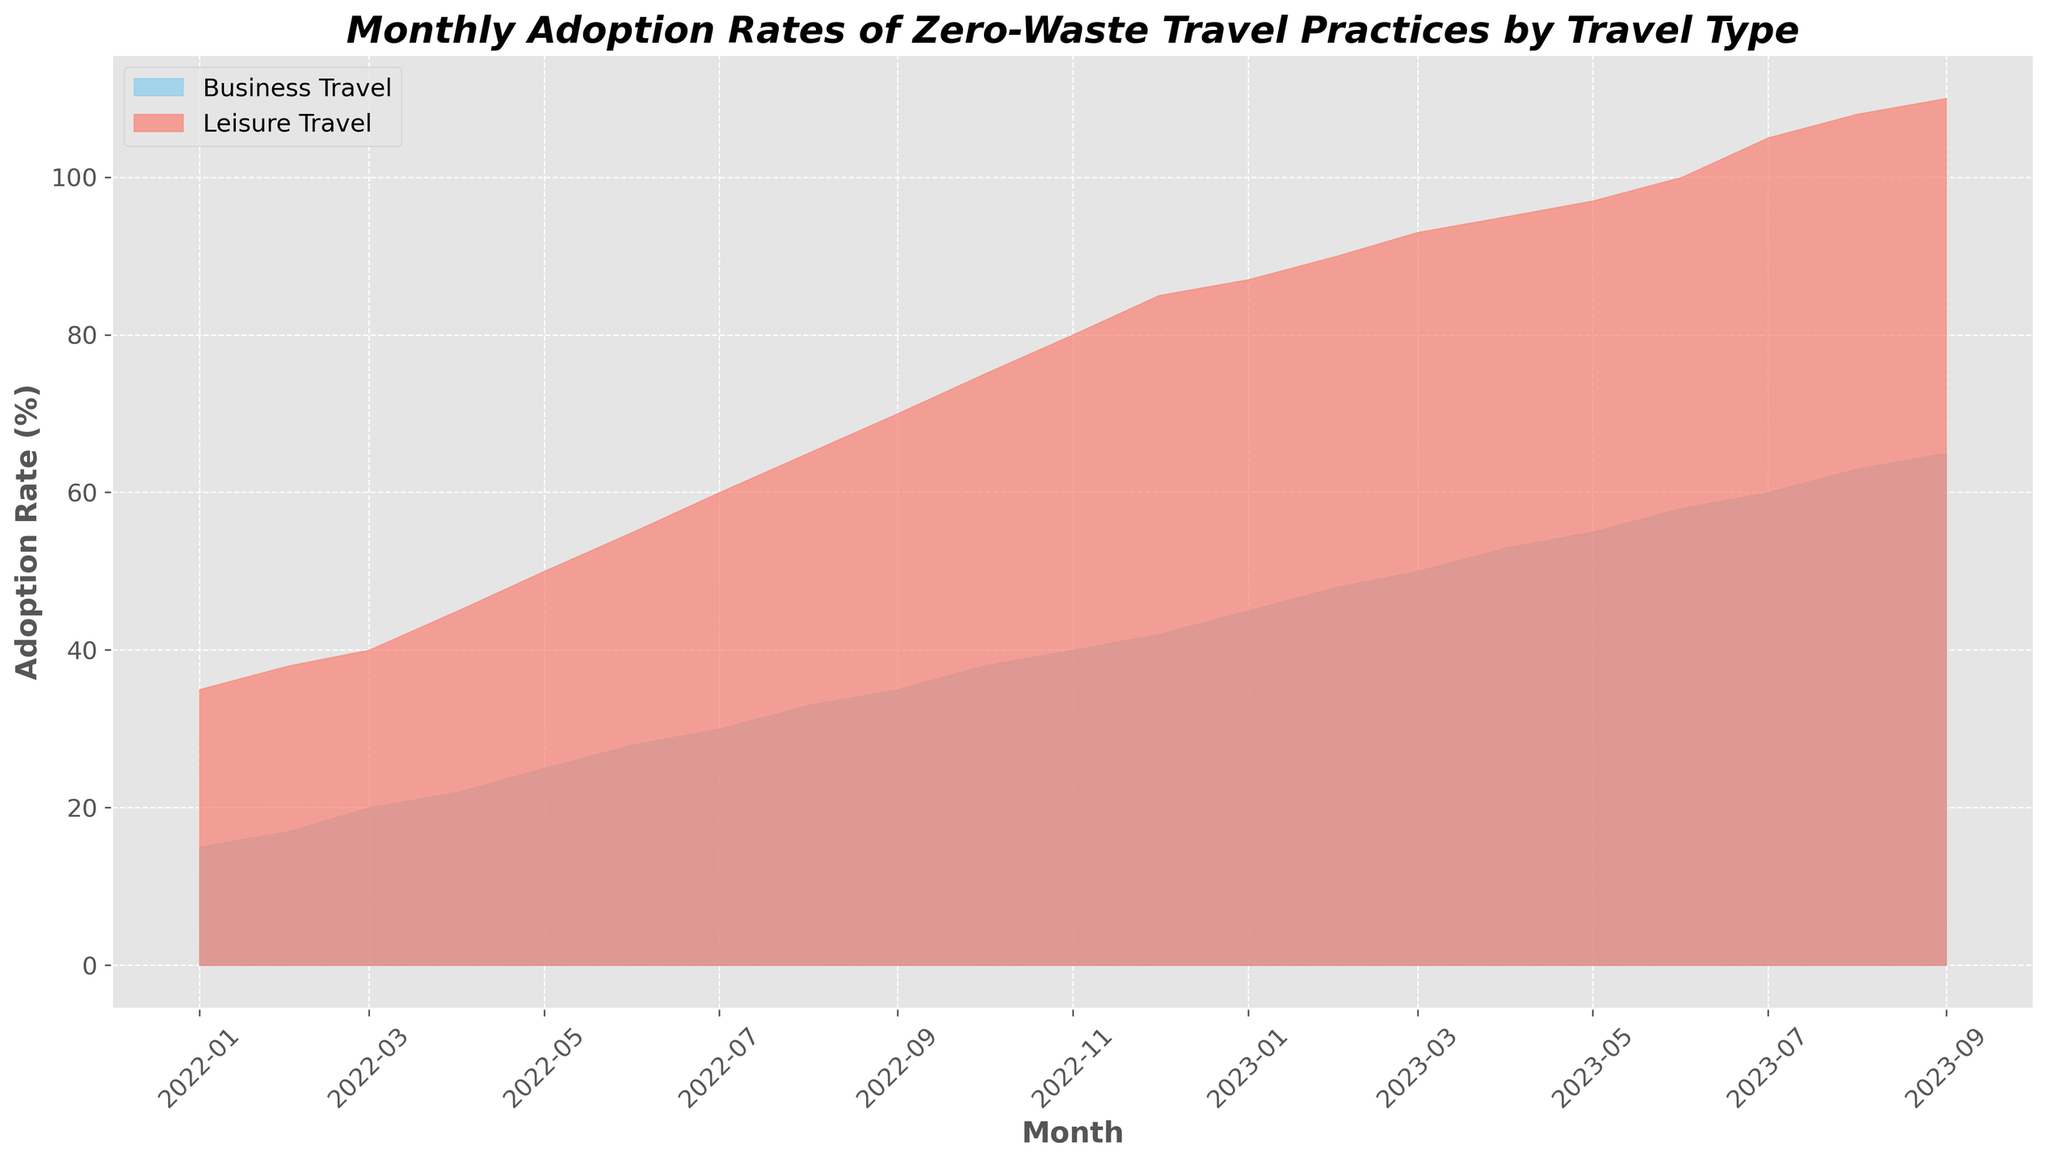What's the adoption rate difference between Business and Leisure Travel in January 2023? To find the difference in adoption rates for January 2023, locate the adoption rates for both Business Travel and Leisure Travel on the chart at January 2023. The rate for Business Travel is 45% and for Leisure Travel is 87%. Subtract the Business rate from the Leisure rate: 87% - 45% = 42%
Answer: 42% In which month did Leisure Travel first reach an adoption rate of 100%? Check the Leisure Travel line on the chart and find the month when it first hits 100%. According to the data, leisure travel reaches 100% adoption in June 2023
Answer: June 2023 Which type of travel shows a more rapid increase in adoption rates between January 2022 and December 2022? Compare the adoption rates of both travel types from January 2022 to December 2022. Business Travel rates increased from 15% to 42%, which is a 27% increase. Leisure Travel rates increased from 35% to 85%, which is a 50% increase. Hence, Leisure Travel shows a more rapid increase
Answer: Leisure Travel What is the average adoption rate for Business Travel from January 2022 to September 2023? To find the average, add up the monthly adoption rates for Business Travel from January 2022 to September 2023 and then divide by the number of months (21). The sum is 798. Dividing this by 21 gives 798 / 21 = 38%
Answer: 38% During which month is the gap between Business and Leisure Travel adoption rates smallest? Identify the month with the smallest difference between adoption rates for Business and Leisure Travel. The smallest difference is in September 2023, with Business at 65% and Leisure at 110%; the difference is 45%, which is the smallest gap
Answer: September 2023 How many months did it take for Business Travel to reach an adoption rate of 50%? Check the Business Travel line on the chart to determine the month it first reaches 50%, which is March 2023. This is from January 2022 to March 2023, which is 15 months
Answer: 15 months In July 2023, by how much did the adoption rate for Leisure Travel exceed that for Business Travel? Look at the adoption rates for both travel types in July 2023. Business Travel is at 60%, and Leisure Travel is at 105%. The difference is 105% - 60% = 45%
Answer: 45% What's the total sum of adoption rates for Leisure Travel from January 2022 to June 2022? Add up the adoption rates for Leisure Travel from January 2022 to June 2022. The rates are 35%, 38%, 40%, 45%, 50%, and 55%. Their sum is 35 + 38 + 40 + 45 + 50 + 55 = 263%
Answer: 263% In which month did both Business and Leisure Travel rates increase by exactly 3% from the previous month? Analyze the changes month by month for both Business and Leisure Travel. This occurs in February 2023, where Business Travel increases from 42% to 45% (3%) and Leisure Travel increases from 85% to 87% (also 3%)
Answer: February 2023 